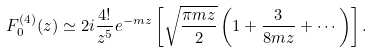Convert formula to latex. <formula><loc_0><loc_0><loc_500><loc_500>F _ { 0 } ^ { ( 4 ) } ( z ) \simeq 2 i \frac { 4 ! } { z ^ { 5 } } e ^ { - m z } \left [ \sqrt { \frac { \pi m z } { 2 } } \left ( 1 + \frac { 3 } { 8 m z } + \cdots \right ) \right ] .</formula> 